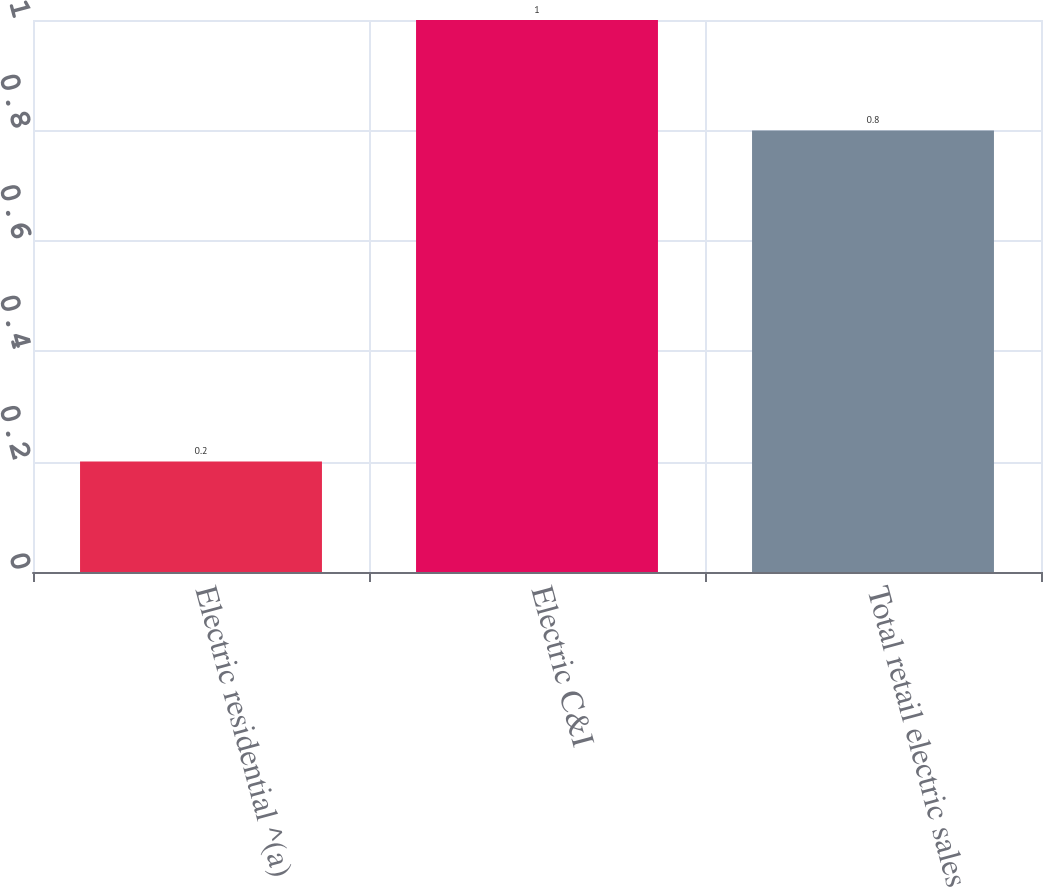Convert chart. <chart><loc_0><loc_0><loc_500><loc_500><bar_chart><fcel>Electric residential ^(a)<fcel>Electric C&I<fcel>Total retail electric sales<nl><fcel>0.2<fcel>1<fcel>0.8<nl></chart> 